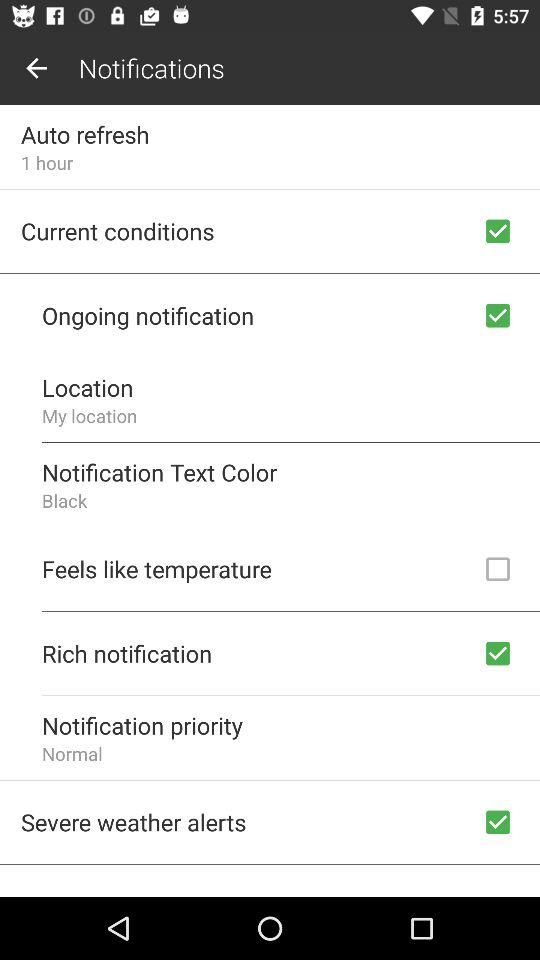Which notification settings are checked? The checked notification settings are "Current conditions", "Ongoing notifications", "Rich notifications" and "Severe weather alerts". 